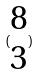Convert formula to latex. <formula><loc_0><loc_0><loc_500><loc_500>( \begin{matrix} 8 \\ 3 \end{matrix} )</formula> 